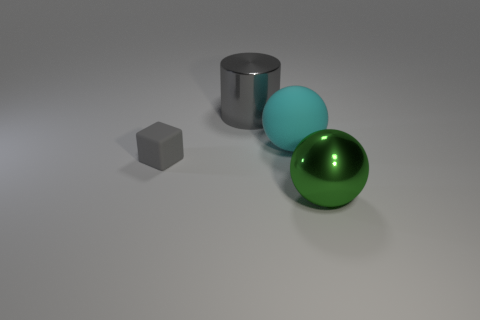Add 4 tiny metal objects. How many objects exist? 8 Subtract all cylinders. How many objects are left? 3 Add 3 gray cylinders. How many gray cylinders exist? 4 Subtract 0 gray spheres. How many objects are left? 4 Subtract all green metallic balls. Subtract all tiny gray matte blocks. How many objects are left? 2 Add 3 large cyan balls. How many large cyan balls are left? 4 